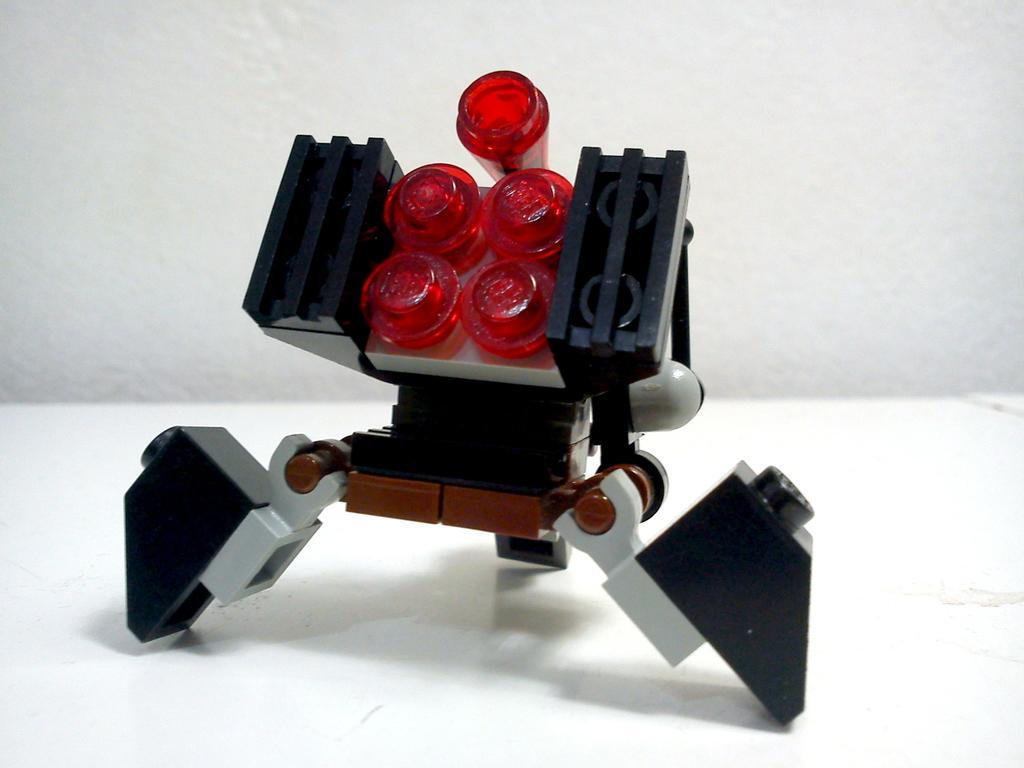Describe this image in one or two sentences. In this image I can see a toy in the front. I can see colour of this toy is black, white and red. I can also see white colour in the background. 